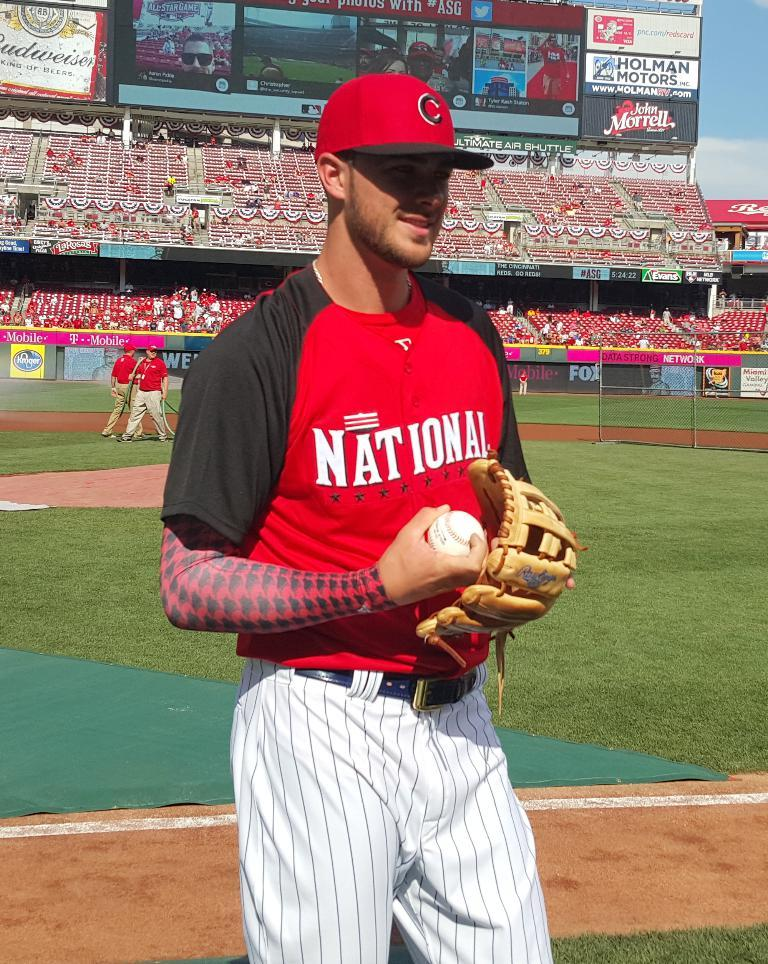<image>
Relay a brief, clear account of the picture shown. A man wearing a red and black baseball shirt with the word national on his chest. 